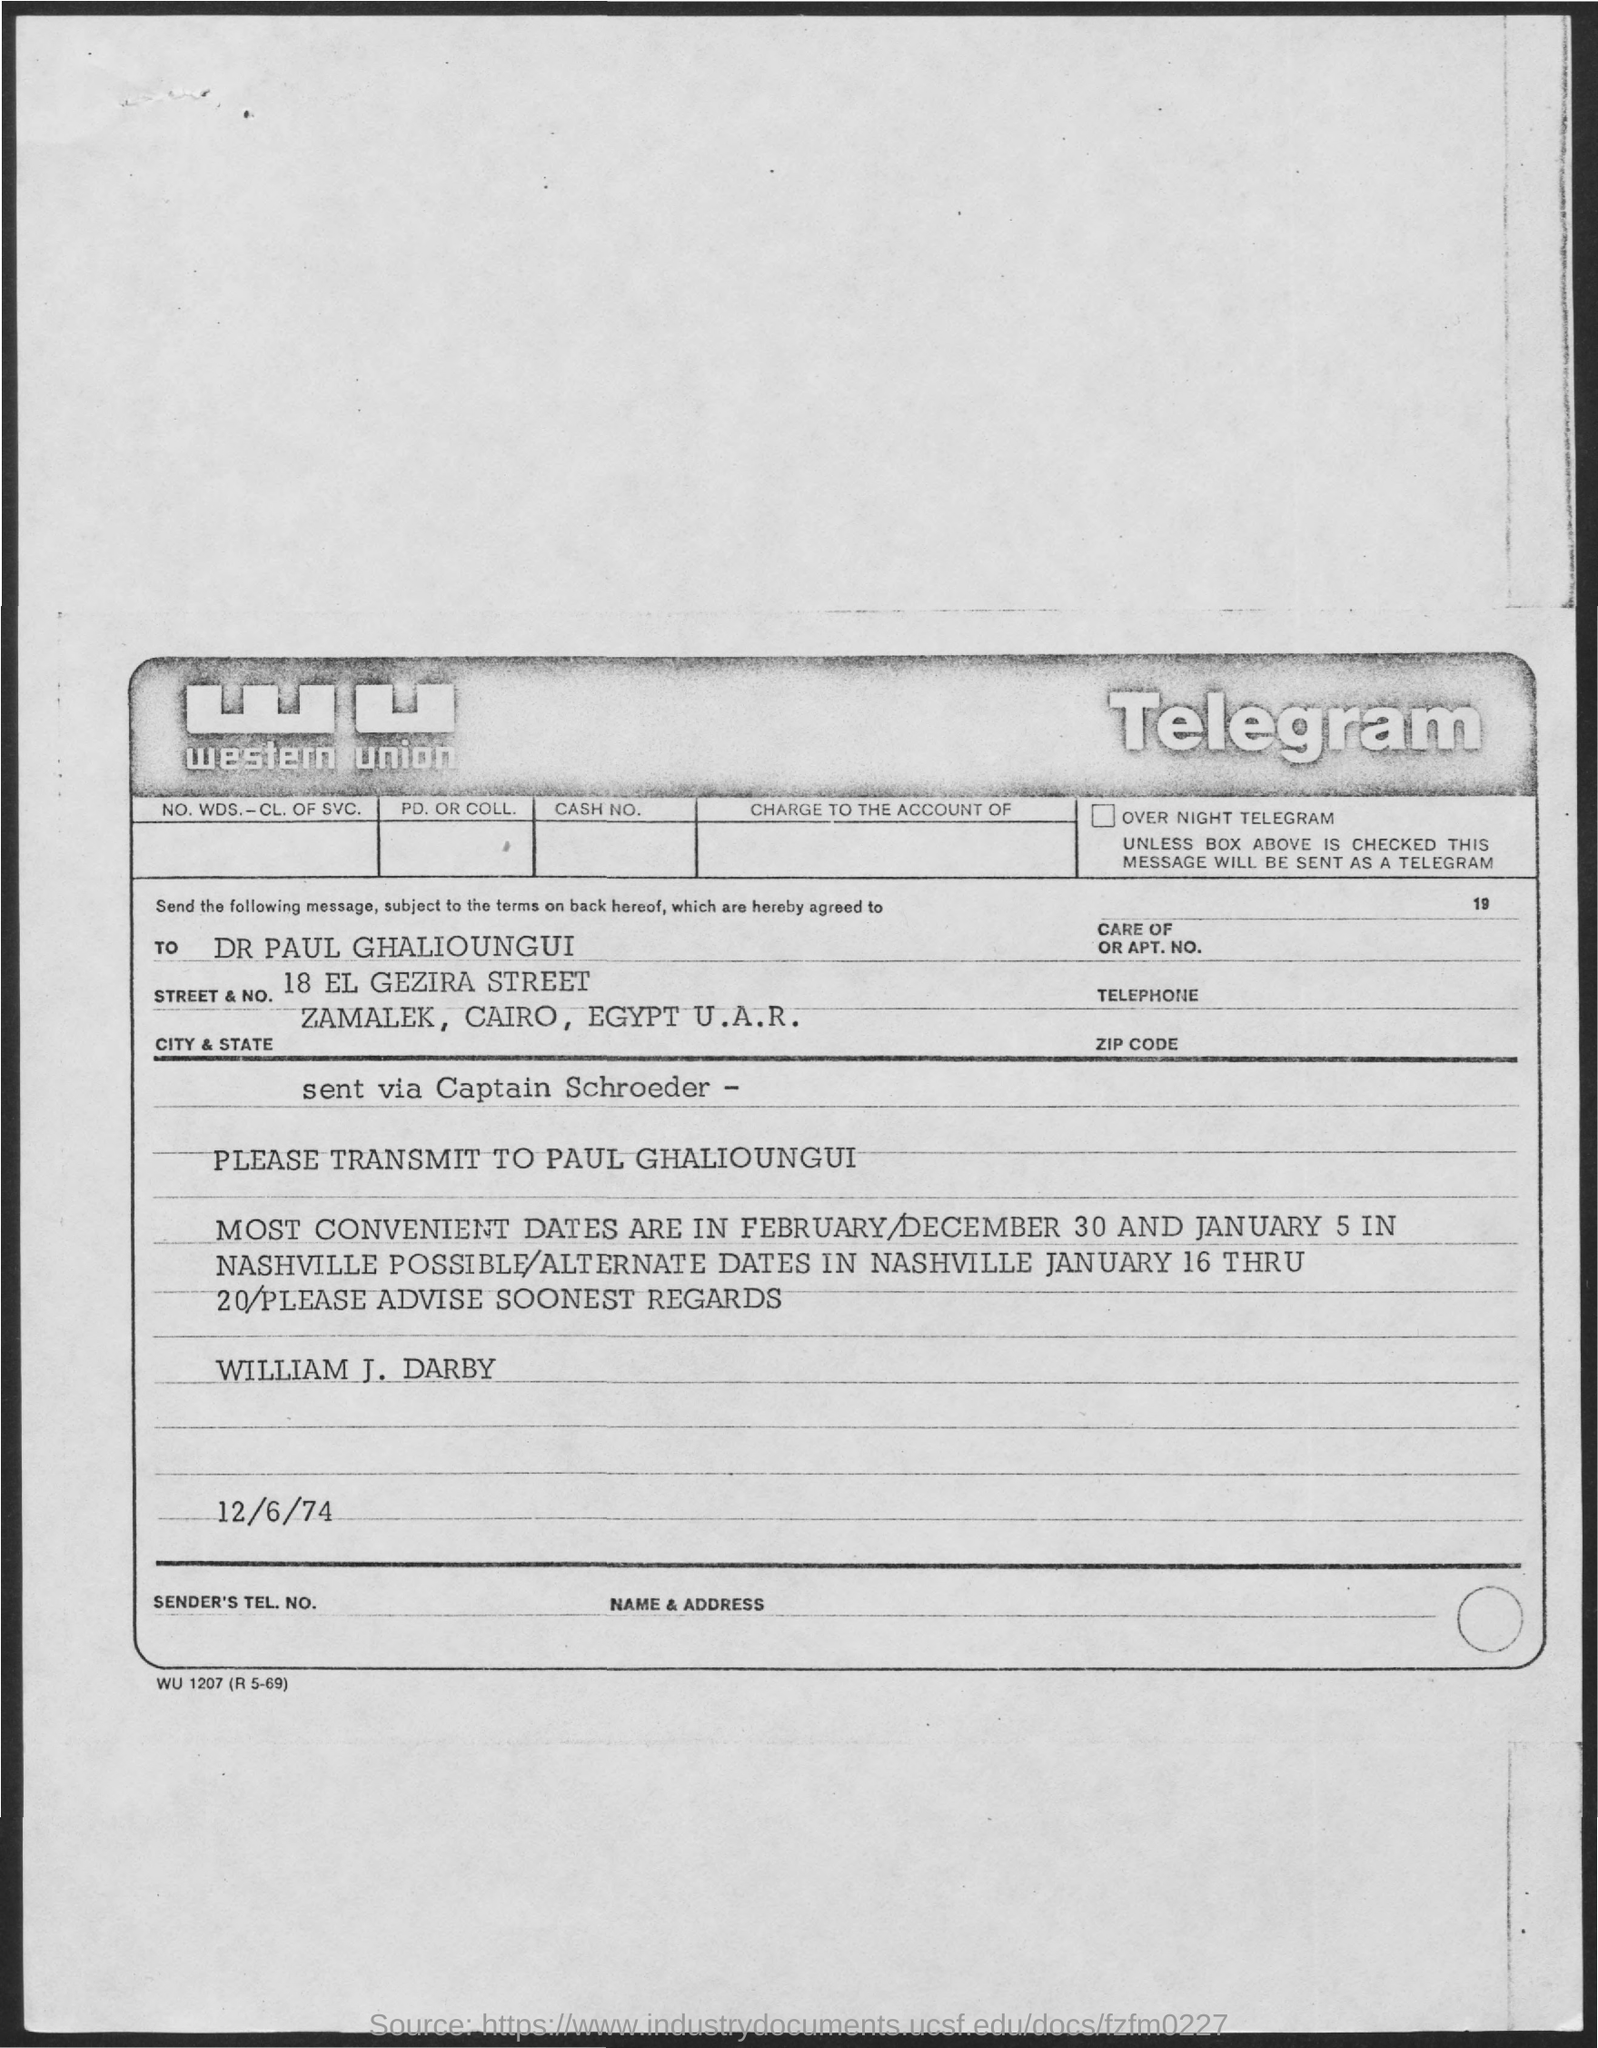List a handful of essential elements in this visual. The location described is Zamalek, Cairo, Egypt, which is part of the United Arab Republic. The most convenient dates are February 30 and January 5. The date of the Telegram is December 6th, 1974. The message "Who is this telegram from? William J. Darby.." is a question that is asking for information about the sender of the telegram. 18 El Gezira Street is located on El Gezira Street. 